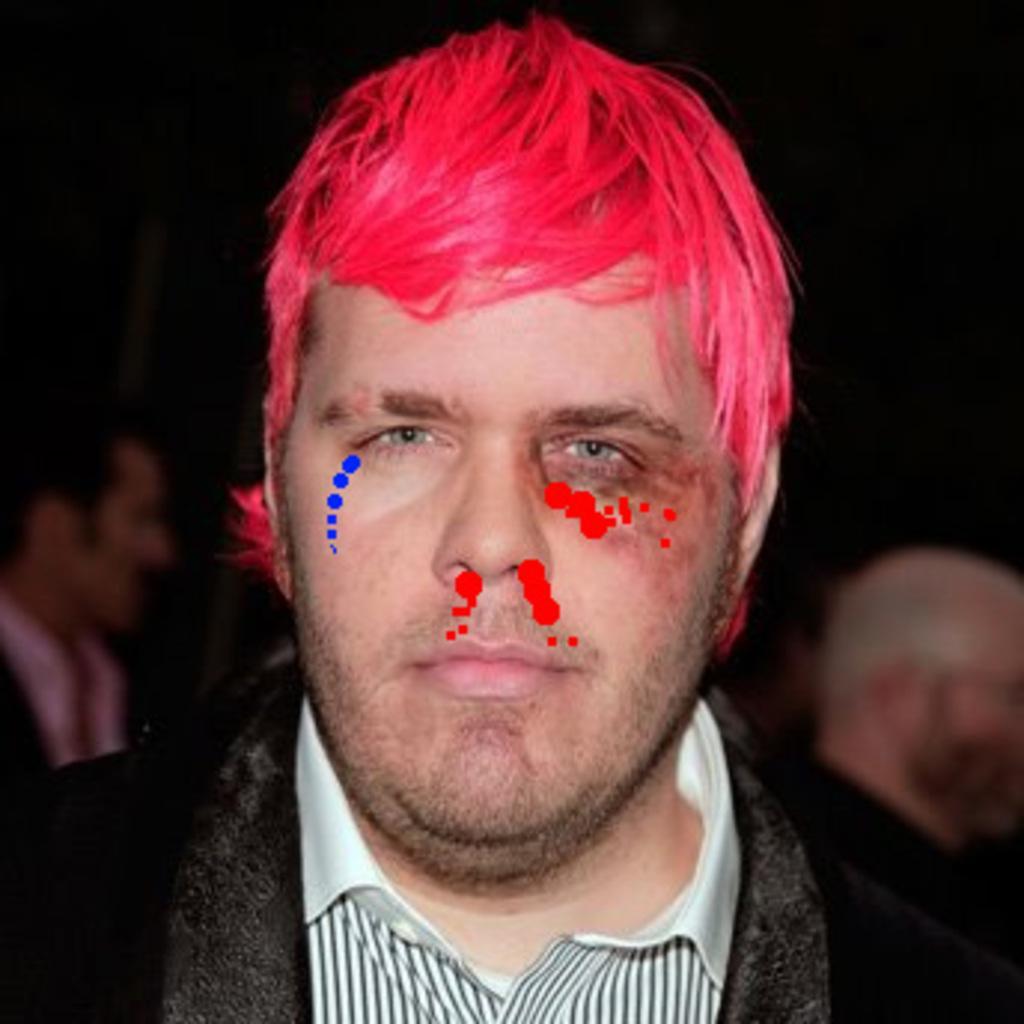Describe this image in one or two sentences. There is man. In the background it is dark and we can see people. 